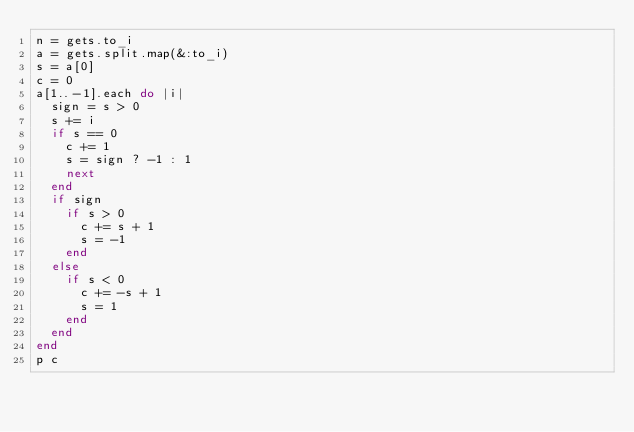Convert code to text. <code><loc_0><loc_0><loc_500><loc_500><_Ruby_>n = gets.to_i
a = gets.split.map(&:to_i)
s = a[0]
c = 0
a[1..-1].each do |i|
  sign = s > 0
  s += i
  if s == 0
    c += 1
    s = sign ? -1 : 1
    next
  end
  if sign
    if s > 0
      c += s + 1
      s = -1
    end
  else
    if s < 0
      c += -s + 1
      s = 1
    end
  end
end
p c
</code> 